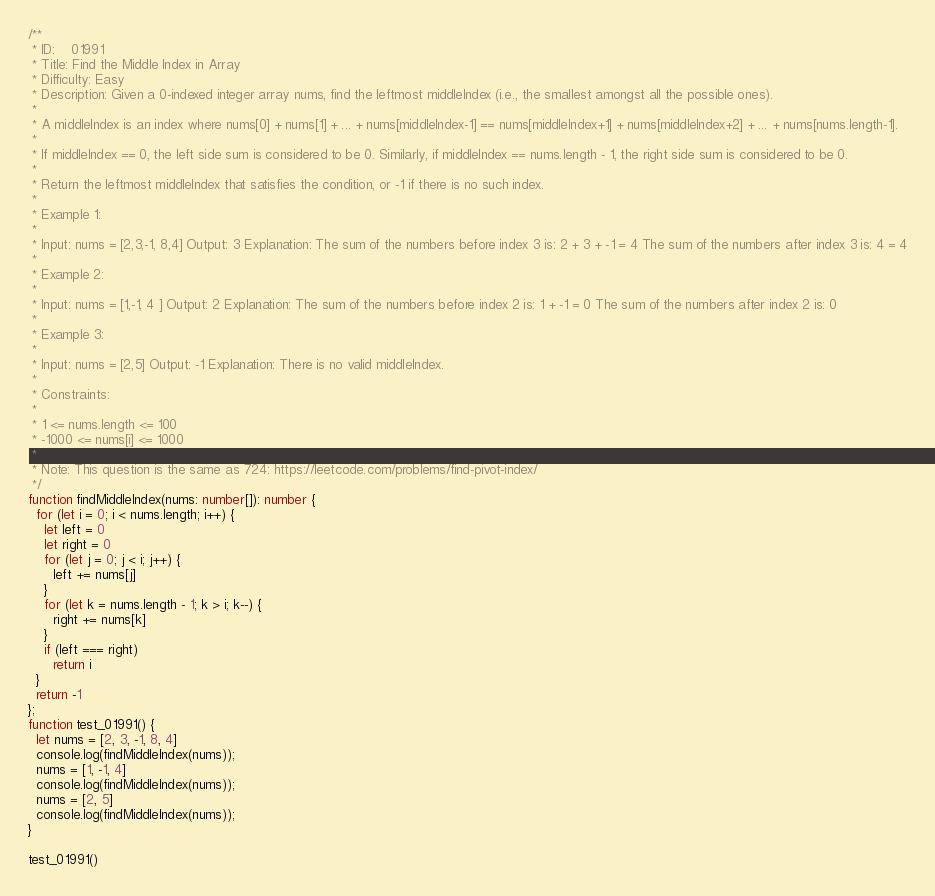Convert code to text. <code><loc_0><loc_0><loc_500><loc_500><_TypeScript_>/**
 * ID:    01991
 * Title: Find the Middle Index in Array
 * Difficulty: Easy
 * Description: Given a 0-indexed integer array nums, find the leftmost middleIndex (i.e., the smallest amongst all the possible ones).
 *
 * A middleIndex is an index where nums[0] + nums[1] + ... + nums[middleIndex-1] == nums[middleIndex+1] + nums[middleIndex+2] + ... + nums[nums.length-1].
 *
 * If middleIndex == 0, the left side sum is considered to be 0. Similarly, if middleIndex == nums.length - 1, the right side sum is considered to be 0.
 *
 * Return the leftmost middleIndex that satisfies the condition, or -1 if there is no such index.
 *
 * Example 1:
 *
 * Input: nums = [2,3,-1, 8,4] Output: 3 Explanation: The sum of the numbers before index 3 is: 2 + 3 + -1 = 4 The sum of the numbers after index 3 is: 4 = 4
 *
 * Example 2:
 *
 * Input: nums = [1,-1, 4 ] Output: 2 Explanation: The sum of the numbers before index 2 is: 1 + -1 = 0 The sum of the numbers after index 2 is: 0
 *
 * Example 3:
 *
 * Input: nums = [2,5] Output: -1 Explanation: There is no valid middleIndex.
 *
 * Constraints:
 *
 * 1 <= nums.length <= 100
 * -1000 <= nums[i] <= 1000
 *
 * Note: This question is the same as 724: https://leetcode.com/problems/find-pivot-index/
 */
function findMiddleIndex(nums: number[]): number {
  for (let i = 0; i < nums.length; i++) {
    let left = 0
    let right = 0
    for (let j = 0; j < i; j++) {
      left += nums[j]
    }
    for (let k = nums.length - 1; k > i; k--) {
      right += nums[k]
    }
    if (left === right)
      return i
  }
  return -1
};
function test_01991() {
  let nums = [2, 3, -1, 8, 4]
  console.log(findMiddleIndex(nums));
  nums = [1, -1, 4]
  console.log(findMiddleIndex(nums));
  nums = [2, 5]
  console.log(findMiddleIndex(nums));
}

test_01991()
</code> 